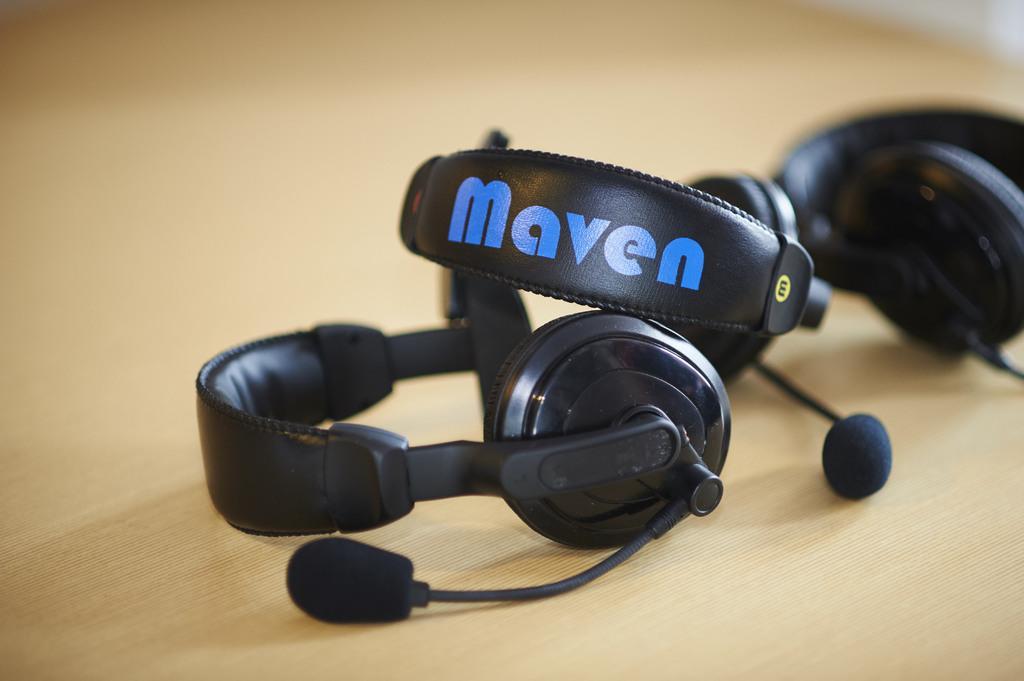In one or two sentences, can you explain what this image depicts? In this image we can see some headsets on the table. 